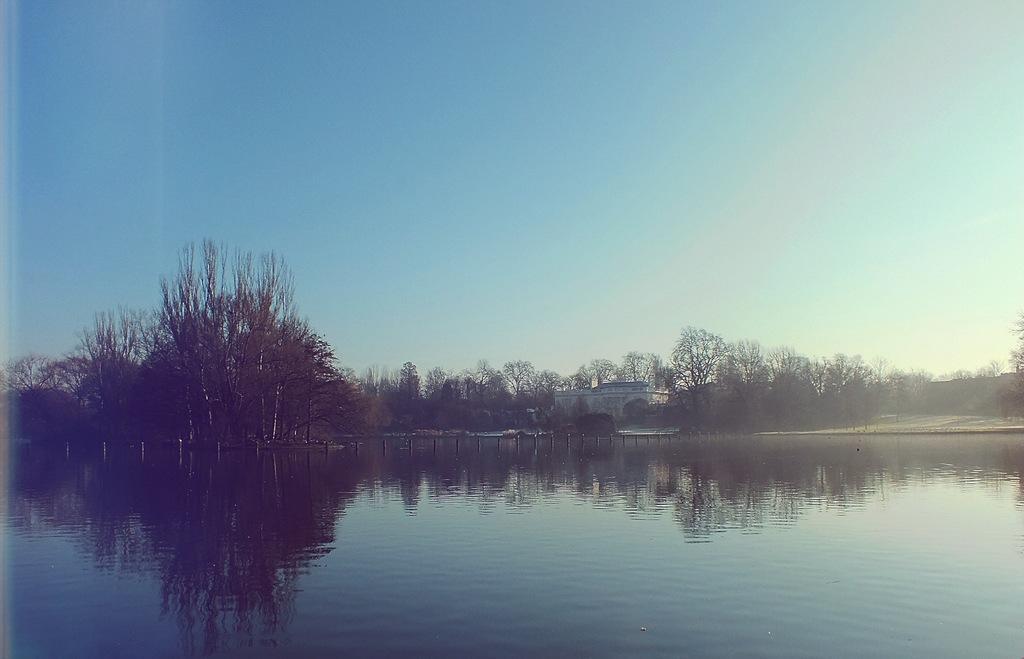Could you give a brief overview of what you see in this image? In this picture we can see few poles in the water, in the background we can find few trees and a house. 